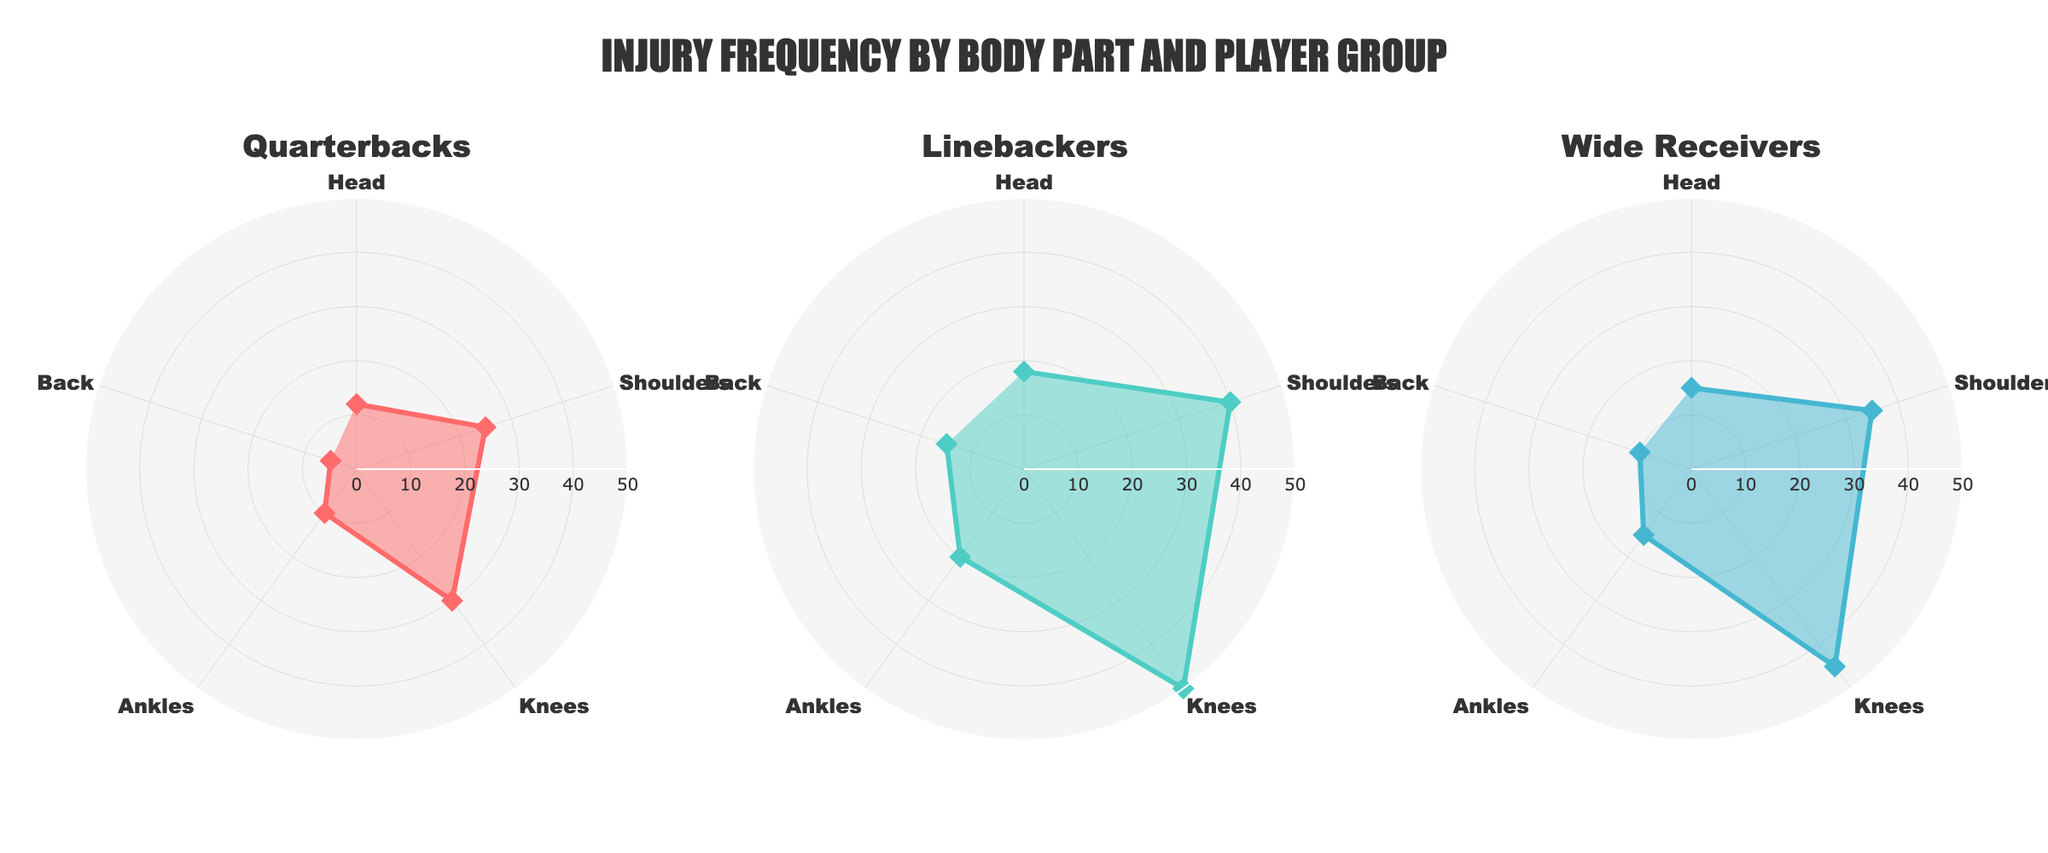What's the title of the figure? The title is positioned at the top of the figure and is clearly visible with a larger font size than other text elements.
Answer: INJURY FREQUENCY BY BODY PART AND PLAYER GROUP Which player group has the highest injury frequency for shoulders? By looking at the "Shoulders" part of the polar chart for all player groups, the Linebackers have the highest frequency.
Answer: Linebackers What is the total number of injuries for the Quarterbacks group? Sum the frequencies of injuries for all body parts in the Quarterbacks subplot: Head (12) + Shoulders (25) + Knees (30) + Ankles (10) + Back (5).
Answer: 82 Compare the injury frequency for knees between Quarterbacks and Linebackers. Which has more? For the "Knees" part of the polar chart, the number is 30 for Quarterbacks and 50 for Linebackers. Therefore, Linebackers have a higher frequency.
Answer: Linebackers Which body part has the lowest injury frequency across all player groups? On each subplot, the "Back" part has the lowest numbers, making it the lowest across player groups.
Answer: Back What is the average injury frequency for Wide Receivers? Sum the frequencies for Wide Receivers (Head: 15, Shoulders: 35, Knees: 45, Ankles: 15, Back: 10) then divide by the number of body parts (5). (15 + 35 + 45 + 15 + 10) / 5 = 24
Answer: 24 Are there any body parts where Wide Receivers have equal injury frequency to another player group? Examining each body part, only Ankles (15) matches any other group's frequency, specifically Wide Receivers and Quarterbacks.
Answer: Ankles What is the median injury frequency for the Linebackers group? For Linebackers: 18 (Head), 40 (Shoulders), 50 (Knees), 20 (Ankles), 15 (Back). The sorted list is 15, 18, 20, 40, 50. The median is the middle value.
Answer: 20 For which body part does each player group have the highest variation in injury frequency? Look at the difference between the highest and lowest points on each subplot for each body part. For Linebackers, it's Knees; for Quarterbacks, it's Shoulders; for Wide Receivers, it's also Knees.
Answer: Linebackers: Knees, Quarterbacks: Shoulders, Wide Receivers: Knees What player group has the highest average injury frequency overall? Calculate the average for each group by summing their frequencies and dividing by 5: Linebackers: 18.6; Quarterbacks: 16.4; Wide Receivers: 24. Wide Receivers have the highest given the calculated value.
Answer: Wide Receivers 